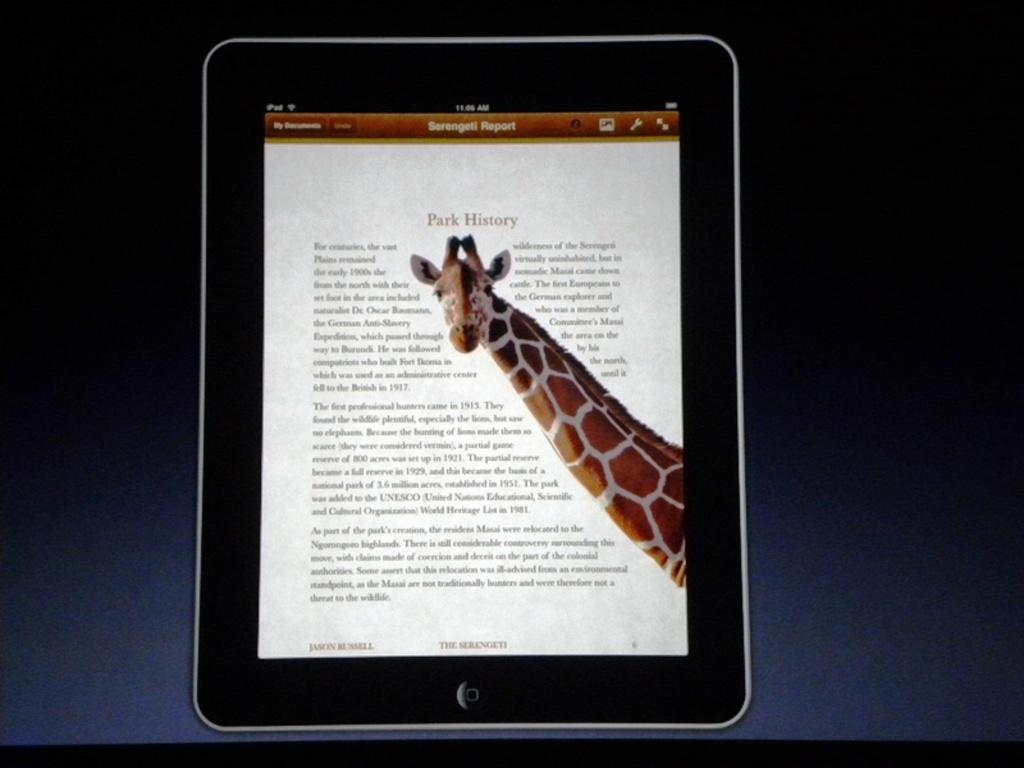What is the main subject of the image? The main subject of the image is a tab. What is depicted on the tab? The tab displays a picture of a giraffe. Is there any text accompanying the picture of the giraffe? Yes, there is text written beside the picture of the giraffe. How many cards are displayed on the page in the image? There is no page or card present in the image; it only features a tab with a picture of a giraffe and accompanying text. 